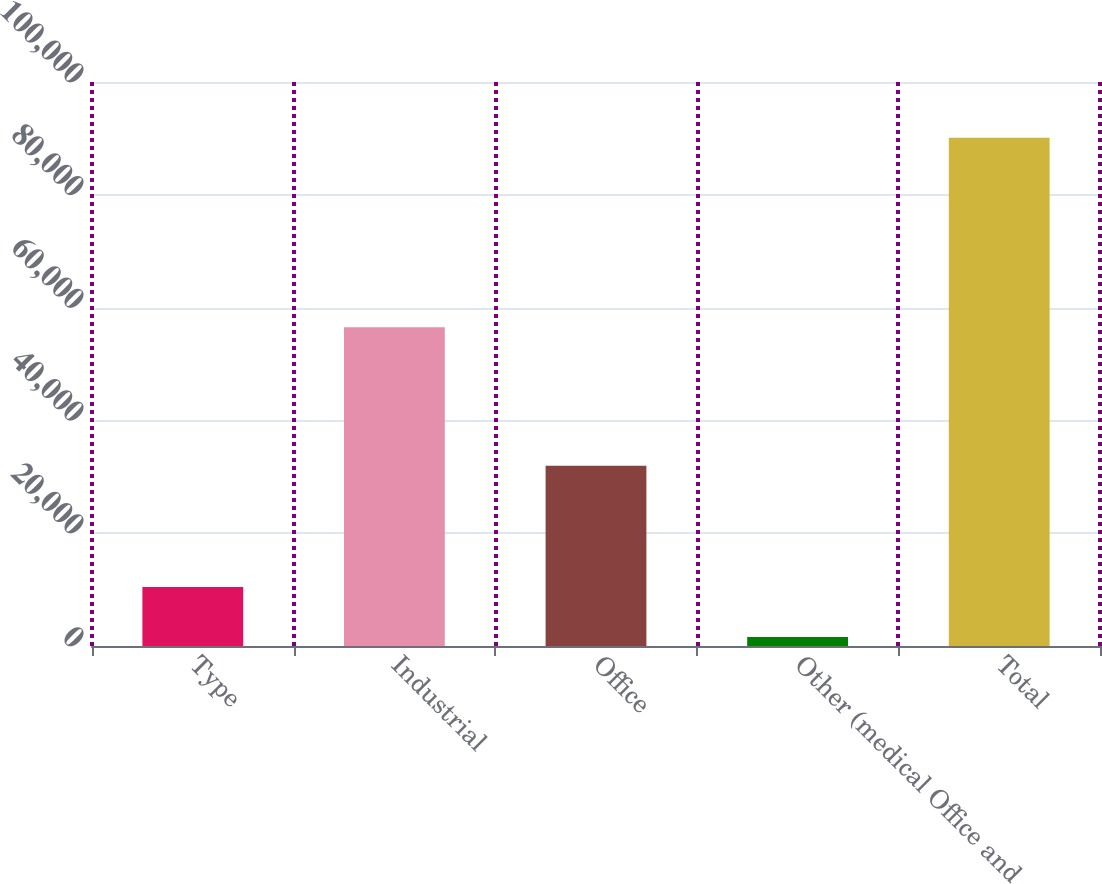Convert chart to OTSL. <chart><loc_0><loc_0><loc_500><loc_500><bar_chart><fcel>Type<fcel>Industrial<fcel>Office<fcel>Other (medical Office and<fcel>Total<nl><fcel>10456.4<fcel>56529<fcel>31965<fcel>1607<fcel>90101<nl></chart> 